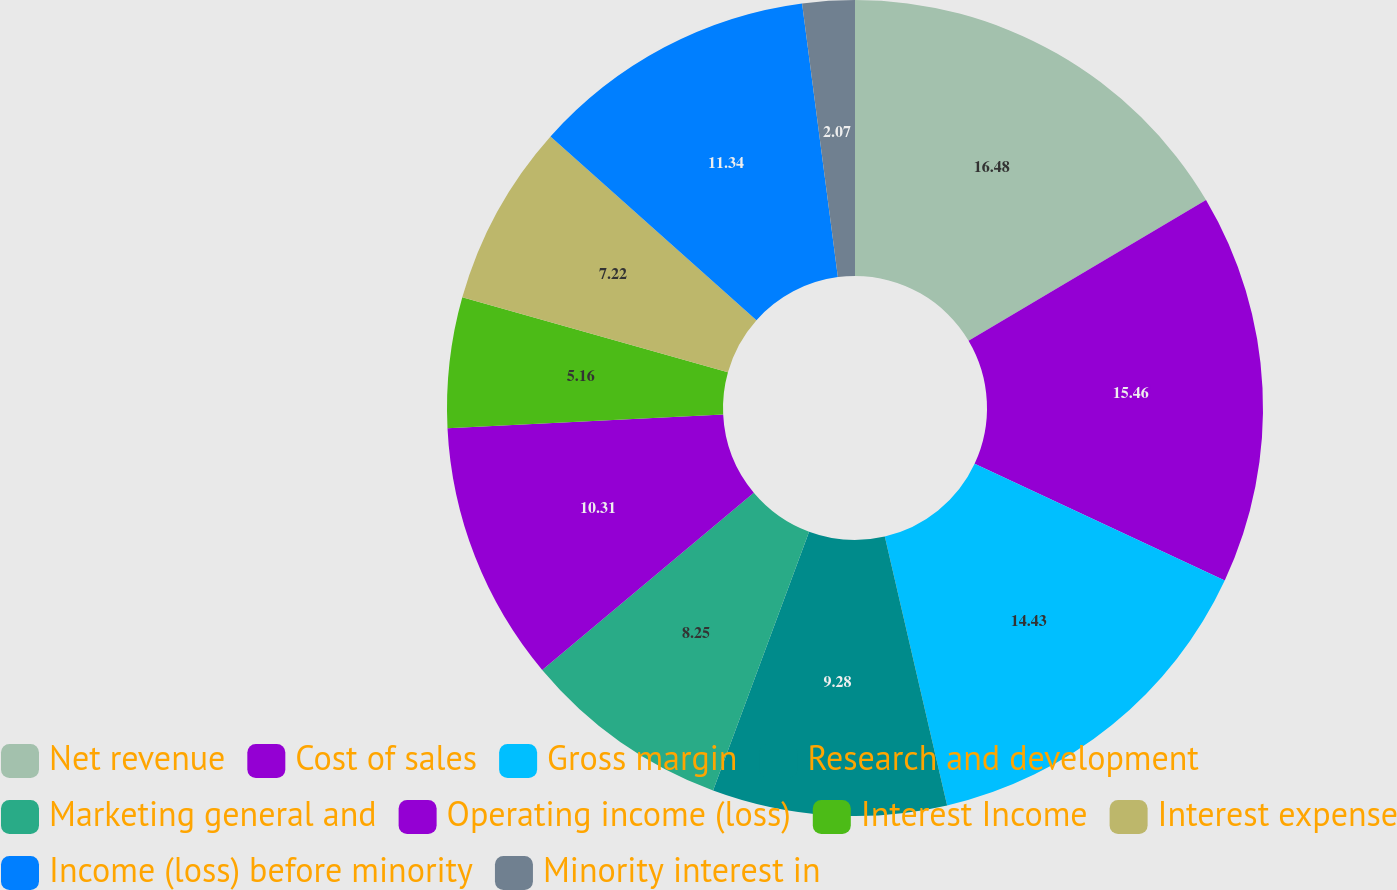<chart> <loc_0><loc_0><loc_500><loc_500><pie_chart><fcel>Net revenue<fcel>Cost of sales<fcel>Gross margin<fcel>Research and development<fcel>Marketing general and<fcel>Operating income (loss)<fcel>Interest Income<fcel>Interest expense<fcel>Income (loss) before minority<fcel>Minority interest in<nl><fcel>16.49%<fcel>15.46%<fcel>14.43%<fcel>9.28%<fcel>8.25%<fcel>10.31%<fcel>5.16%<fcel>7.22%<fcel>11.34%<fcel>2.07%<nl></chart> 